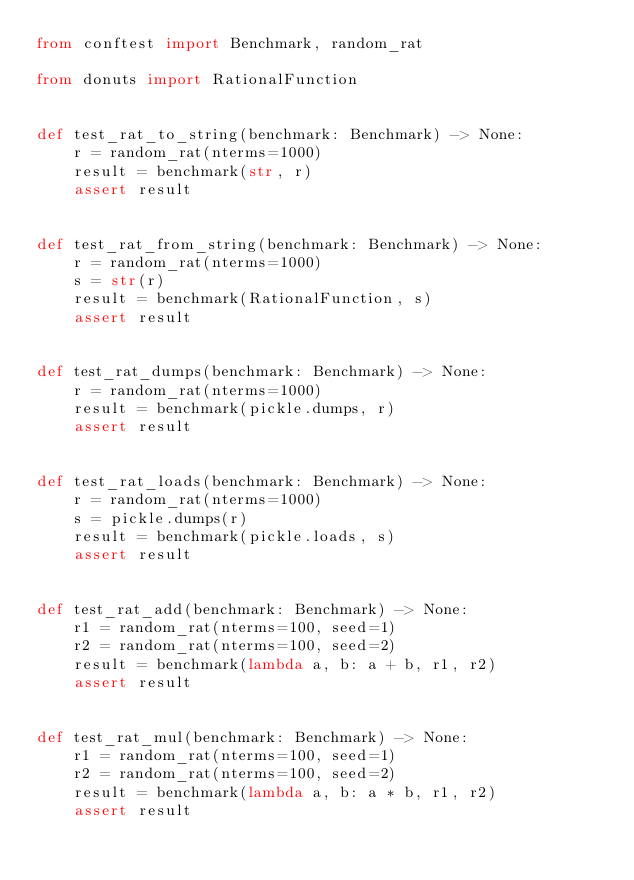Convert code to text. <code><loc_0><loc_0><loc_500><loc_500><_Python_>from conftest import Benchmark, random_rat

from donuts import RationalFunction


def test_rat_to_string(benchmark: Benchmark) -> None:
    r = random_rat(nterms=1000)
    result = benchmark(str, r)
    assert result


def test_rat_from_string(benchmark: Benchmark) -> None:
    r = random_rat(nterms=1000)
    s = str(r)
    result = benchmark(RationalFunction, s)
    assert result


def test_rat_dumps(benchmark: Benchmark) -> None:
    r = random_rat(nterms=1000)
    result = benchmark(pickle.dumps, r)
    assert result


def test_rat_loads(benchmark: Benchmark) -> None:
    r = random_rat(nterms=1000)
    s = pickle.dumps(r)
    result = benchmark(pickle.loads, s)
    assert result


def test_rat_add(benchmark: Benchmark) -> None:
    r1 = random_rat(nterms=100, seed=1)
    r2 = random_rat(nterms=100, seed=2)
    result = benchmark(lambda a, b: a + b, r1, r2)
    assert result


def test_rat_mul(benchmark: Benchmark) -> None:
    r1 = random_rat(nterms=100, seed=1)
    r2 = random_rat(nterms=100, seed=2)
    result = benchmark(lambda a, b: a * b, r1, r2)
    assert result
</code> 